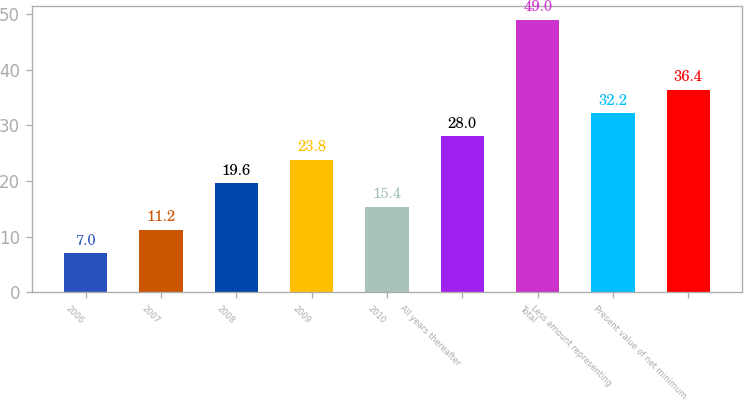Convert chart to OTSL. <chart><loc_0><loc_0><loc_500><loc_500><bar_chart><fcel>2006<fcel>2007<fcel>2008<fcel>2009<fcel>2010<fcel>All years thereafter<fcel>Total<fcel>Less amount representing<fcel>Present value of net minimum<nl><fcel>7<fcel>11.2<fcel>19.6<fcel>23.8<fcel>15.4<fcel>28<fcel>49<fcel>32.2<fcel>36.4<nl></chart> 